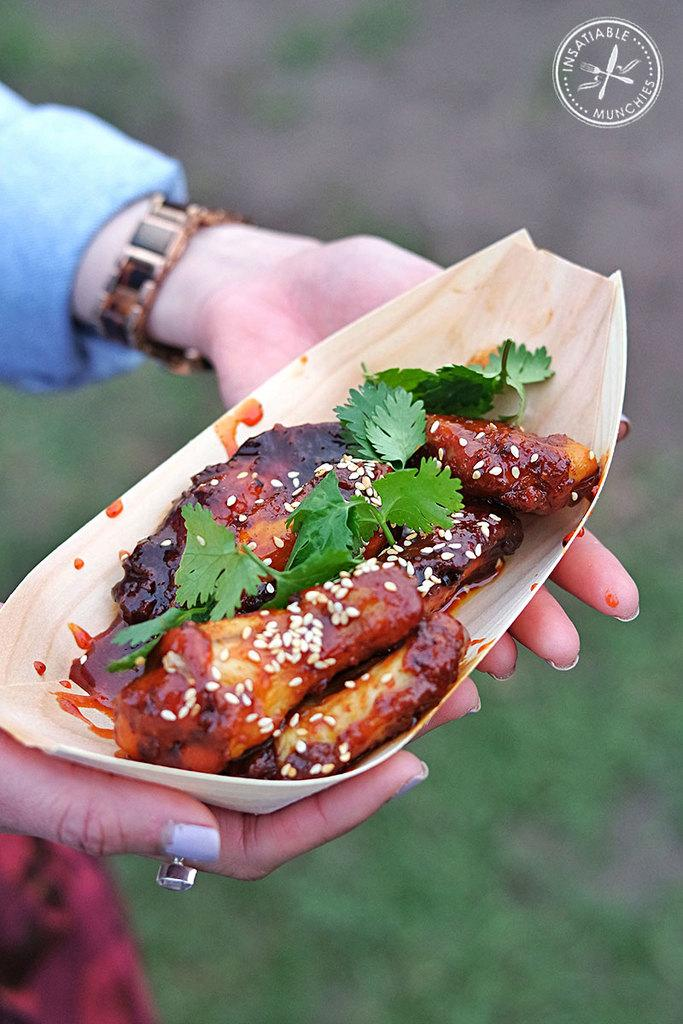What is the main subject of the image? The main subject of the image is food. How is the food being held in the image? The food is being held by a human. Can you describe the background of the image? The background of the image is blurred. Is there any additional information or markings in the image? Yes, there is a watermark in the top right side of the image. What type of desk is visible in the image? There is no desk present in the image. What property is being held by the human in the image? The image only shows food being held by a human, and no property is mentioned or visible. 